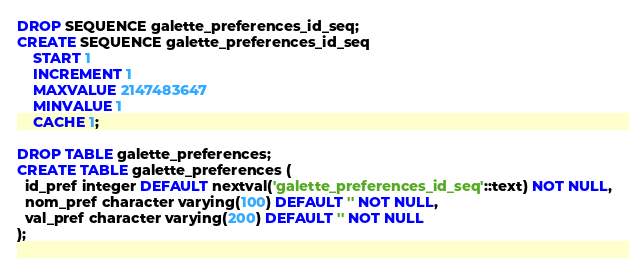<code> <loc_0><loc_0><loc_500><loc_500><_SQL_>DROP SEQUENCE galette_preferences_id_seq;
CREATE SEQUENCE galette_preferences_id_seq
    START 1
    INCREMENT 1
    MAXVALUE 2147483647
    MINVALUE 1
    CACHE 1;
		
DROP TABLE galette_preferences;
CREATE TABLE galette_preferences (
  id_pref integer DEFAULT nextval('galette_preferences_id_seq'::text) NOT NULL,
  nom_pref character varying(100) DEFAULT '' NOT NULL,
  val_pref character varying(200) DEFAULT '' NOT NULL
);
</code> 